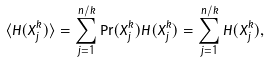<formula> <loc_0><loc_0><loc_500><loc_500>\langle H ( X _ { j } ^ { k } ) \rangle = \sum _ { j = 1 } ^ { n / k } \Pr ( X _ { j } ^ { k } ) H ( X _ { j } ^ { k } ) = \sum _ { j = 1 } ^ { n / k } H ( X _ { j } ^ { k } ) ,</formula> 